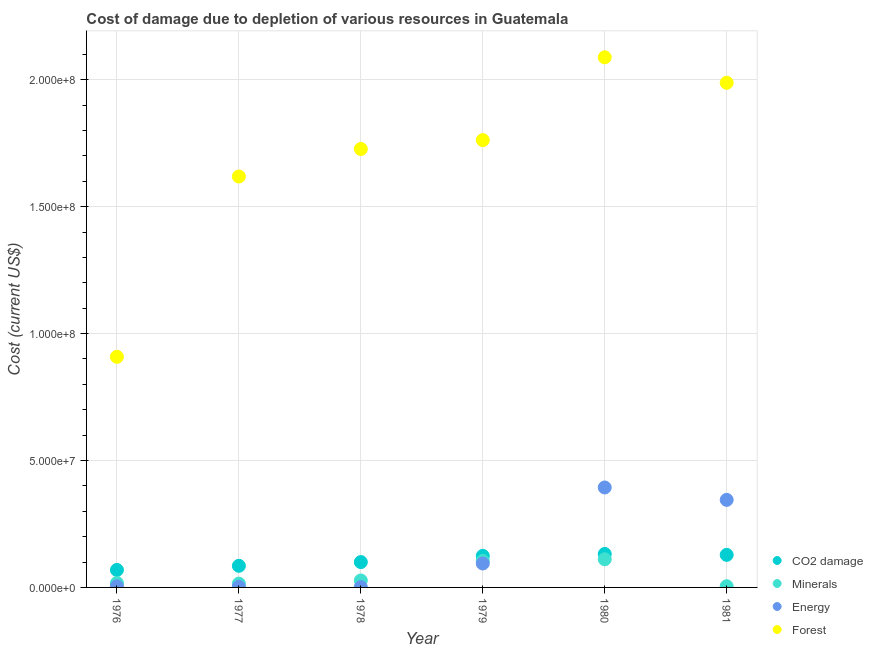Is the number of dotlines equal to the number of legend labels?
Your response must be concise. Yes. What is the cost of damage due to depletion of coal in 1981?
Your answer should be compact. 1.28e+07. Across all years, what is the maximum cost of damage due to depletion of energy?
Your answer should be compact. 3.94e+07. Across all years, what is the minimum cost of damage due to depletion of energy?
Provide a succinct answer. 1.10e+05. In which year was the cost of damage due to depletion of energy maximum?
Offer a terse response. 1980. In which year was the cost of damage due to depletion of coal minimum?
Your response must be concise. 1976. What is the total cost of damage due to depletion of minerals in the graph?
Your response must be concise. 2.80e+07. What is the difference between the cost of damage due to depletion of coal in 1976 and that in 1979?
Your response must be concise. -5.55e+06. What is the difference between the cost of damage due to depletion of minerals in 1981 and the cost of damage due to depletion of forests in 1980?
Give a very brief answer. -2.08e+08. What is the average cost of damage due to depletion of minerals per year?
Keep it short and to the point. 4.67e+06. In the year 1977, what is the difference between the cost of damage due to depletion of minerals and cost of damage due to depletion of coal?
Give a very brief answer. -7.02e+06. What is the ratio of the cost of damage due to depletion of forests in 1980 to that in 1981?
Your answer should be very brief. 1.05. Is the cost of damage due to depletion of forests in 1977 less than that in 1981?
Give a very brief answer. Yes. Is the difference between the cost of damage due to depletion of energy in 1976 and 1977 greater than the difference between the cost of damage due to depletion of forests in 1976 and 1977?
Your answer should be very brief. Yes. What is the difference between the highest and the second highest cost of damage due to depletion of minerals?
Provide a succinct answer. 6.16e+05. What is the difference between the highest and the lowest cost of damage due to depletion of energy?
Make the answer very short. 3.93e+07. Is the sum of the cost of damage due to depletion of coal in 1980 and 1981 greater than the maximum cost of damage due to depletion of energy across all years?
Provide a succinct answer. No. Is it the case that in every year, the sum of the cost of damage due to depletion of forests and cost of damage due to depletion of energy is greater than the sum of cost of damage due to depletion of minerals and cost of damage due to depletion of coal?
Your response must be concise. No. Is it the case that in every year, the sum of the cost of damage due to depletion of coal and cost of damage due to depletion of minerals is greater than the cost of damage due to depletion of energy?
Provide a short and direct response. No. Does the cost of damage due to depletion of forests monotonically increase over the years?
Provide a short and direct response. No. How many years are there in the graph?
Give a very brief answer. 6. What is the difference between two consecutive major ticks on the Y-axis?
Provide a short and direct response. 5.00e+07. Are the values on the major ticks of Y-axis written in scientific E-notation?
Keep it short and to the point. Yes. Does the graph contain any zero values?
Your response must be concise. No. Does the graph contain grids?
Offer a terse response. Yes. Where does the legend appear in the graph?
Provide a short and direct response. Bottom right. How many legend labels are there?
Offer a very short reply. 4. How are the legend labels stacked?
Your response must be concise. Vertical. What is the title of the graph?
Offer a very short reply. Cost of damage due to depletion of various resources in Guatemala . What is the label or title of the Y-axis?
Make the answer very short. Cost (current US$). What is the Cost (current US$) in CO2 damage in 1976?
Keep it short and to the point. 6.88e+06. What is the Cost (current US$) of Minerals in 1976?
Your answer should be compact. 1.73e+06. What is the Cost (current US$) in Energy in 1976?
Your answer should be compact. 4.30e+05. What is the Cost (current US$) in Forest in 1976?
Your answer should be compact. 9.09e+07. What is the Cost (current US$) in CO2 damage in 1977?
Make the answer very short. 8.52e+06. What is the Cost (current US$) in Minerals in 1977?
Offer a very short reply. 1.50e+06. What is the Cost (current US$) in Energy in 1977?
Your response must be concise. 2.50e+05. What is the Cost (current US$) of Forest in 1977?
Make the answer very short. 1.62e+08. What is the Cost (current US$) of CO2 damage in 1978?
Offer a terse response. 9.99e+06. What is the Cost (current US$) in Minerals in 1978?
Give a very brief answer. 2.74e+06. What is the Cost (current US$) in Energy in 1978?
Make the answer very short. 1.10e+05. What is the Cost (current US$) in Forest in 1978?
Offer a very short reply. 1.73e+08. What is the Cost (current US$) of CO2 damage in 1979?
Make the answer very short. 1.24e+07. What is the Cost (current US$) in Minerals in 1979?
Make the answer very short. 1.05e+07. What is the Cost (current US$) of Energy in 1979?
Your answer should be very brief. 9.43e+06. What is the Cost (current US$) in Forest in 1979?
Your response must be concise. 1.76e+08. What is the Cost (current US$) in CO2 damage in 1980?
Your response must be concise. 1.32e+07. What is the Cost (current US$) of Minerals in 1980?
Offer a very short reply. 1.11e+07. What is the Cost (current US$) in Energy in 1980?
Make the answer very short. 3.94e+07. What is the Cost (current US$) of Forest in 1980?
Keep it short and to the point. 2.09e+08. What is the Cost (current US$) in CO2 damage in 1981?
Provide a short and direct response. 1.28e+07. What is the Cost (current US$) of Minerals in 1981?
Offer a terse response. 4.74e+05. What is the Cost (current US$) in Energy in 1981?
Offer a very short reply. 3.45e+07. What is the Cost (current US$) in Forest in 1981?
Offer a very short reply. 1.99e+08. Across all years, what is the maximum Cost (current US$) in CO2 damage?
Your answer should be compact. 1.32e+07. Across all years, what is the maximum Cost (current US$) in Minerals?
Your answer should be very brief. 1.11e+07. Across all years, what is the maximum Cost (current US$) in Energy?
Offer a very short reply. 3.94e+07. Across all years, what is the maximum Cost (current US$) in Forest?
Make the answer very short. 2.09e+08. Across all years, what is the minimum Cost (current US$) of CO2 damage?
Your answer should be very brief. 6.88e+06. Across all years, what is the minimum Cost (current US$) of Minerals?
Give a very brief answer. 4.74e+05. Across all years, what is the minimum Cost (current US$) in Energy?
Keep it short and to the point. 1.10e+05. Across all years, what is the minimum Cost (current US$) in Forest?
Offer a terse response. 9.09e+07. What is the total Cost (current US$) in CO2 damage in the graph?
Ensure brevity in your answer.  6.38e+07. What is the total Cost (current US$) of Minerals in the graph?
Provide a short and direct response. 2.80e+07. What is the total Cost (current US$) in Energy in the graph?
Provide a short and direct response. 8.41e+07. What is the total Cost (current US$) of Forest in the graph?
Your answer should be very brief. 1.01e+09. What is the difference between the Cost (current US$) in CO2 damage in 1976 and that in 1977?
Keep it short and to the point. -1.64e+06. What is the difference between the Cost (current US$) in Minerals in 1976 and that in 1977?
Ensure brevity in your answer.  2.34e+05. What is the difference between the Cost (current US$) of Energy in 1976 and that in 1977?
Offer a very short reply. 1.80e+05. What is the difference between the Cost (current US$) of Forest in 1976 and that in 1977?
Keep it short and to the point. -7.10e+07. What is the difference between the Cost (current US$) in CO2 damage in 1976 and that in 1978?
Keep it short and to the point. -3.10e+06. What is the difference between the Cost (current US$) in Minerals in 1976 and that in 1978?
Provide a succinct answer. -1.01e+06. What is the difference between the Cost (current US$) of Energy in 1976 and that in 1978?
Your answer should be very brief. 3.21e+05. What is the difference between the Cost (current US$) of Forest in 1976 and that in 1978?
Your answer should be compact. -8.19e+07. What is the difference between the Cost (current US$) in CO2 damage in 1976 and that in 1979?
Keep it short and to the point. -5.55e+06. What is the difference between the Cost (current US$) of Minerals in 1976 and that in 1979?
Keep it short and to the point. -8.75e+06. What is the difference between the Cost (current US$) of Energy in 1976 and that in 1979?
Make the answer very short. -9.00e+06. What is the difference between the Cost (current US$) in Forest in 1976 and that in 1979?
Your answer should be very brief. -8.54e+07. What is the difference between the Cost (current US$) of CO2 damage in 1976 and that in 1980?
Offer a very short reply. -6.30e+06. What is the difference between the Cost (current US$) of Minerals in 1976 and that in 1980?
Offer a very short reply. -9.37e+06. What is the difference between the Cost (current US$) in Energy in 1976 and that in 1980?
Provide a short and direct response. -3.89e+07. What is the difference between the Cost (current US$) in Forest in 1976 and that in 1980?
Offer a very short reply. -1.18e+08. What is the difference between the Cost (current US$) in CO2 damage in 1976 and that in 1981?
Give a very brief answer. -5.94e+06. What is the difference between the Cost (current US$) of Minerals in 1976 and that in 1981?
Your answer should be very brief. 1.26e+06. What is the difference between the Cost (current US$) in Energy in 1976 and that in 1981?
Give a very brief answer. -3.41e+07. What is the difference between the Cost (current US$) of Forest in 1976 and that in 1981?
Make the answer very short. -1.08e+08. What is the difference between the Cost (current US$) of CO2 damage in 1977 and that in 1978?
Your answer should be compact. -1.47e+06. What is the difference between the Cost (current US$) of Minerals in 1977 and that in 1978?
Provide a short and direct response. -1.25e+06. What is the difference between the Cost (current US$) of Energy in 1977 and that in 1978?
Offer a very short reply. 1.41e+05. What is the difference between the Cost (current US$) of Forest in 1977 and that in 1978?
Provide a short and direct response. -1.08e+07. What is the difference between the Cost (current US$) of CO2 damage in 1977 and that in 1979?
Give a very brief answer. -3.92e+06. What is the difference between the Cost (current US$) in Minerals in 1977 and that in 1979?
Offer a terse response. -8.98e+06. What is the difference between the Cost (current US$) in Energy in 1977 and that in 1979?
Ensure brevity in your answer.  -9.18e+06. What is the difference between the Cost (current US$) of Forest in 1977 and that in 1979?
Your response must be concise. -1.43e+07. What is the difference between the Cost (current US$) in CO2 damage in 1977 and that in 1980?
Provide a succinct answer. -4.66e+06. What is the difference between the Cost (current US$) in Minerals in 1977 and that in 1980?
Offer a terse response. -9.60e+06. What is the difference between the Cost (current US$) in Energy in 1977 and that in 1980?
Your response must be concise. -3.91e+07. What is the difference between the Cost (current US$) of Forest in 1977 and that in 1980?
Give a very brief answer. -4.70e+07. What is the difference between the Cost (current US$) in CO2 damage in 1977 and that in 1981?
Offer a terse response. -4.31e+06. What is the difference between the Cost (current US$) of Minerals in 1977 and that in 1981?
Keep it short and to the point. 1.02e+06. What is the difference between the Cost (current US$) of Energy in 1977 and that in 1981?
Keep it short and to the point. -3.42e+07. What is the difference between the Cost (current US$) in Forest in 1977 and that in 1981?
Offer a very short reply. -3.69e+07. What is the difference between the Cost (current US$) in CO2 damage in 1978 and that in 1979?
Offer a very short reply. -2.45e+06. What is the difference between the Cost (current US$) of Minerals in 1978 and that in 1979?
Keep it short and to the point. -7.74e+06. What is the difference between the Cost (current US$) in Energy in 1978 and that in 1979?
Offer a terse response. -9.32e+06. What is the difference between the Cost (current US$) in Forest in 1978 and that in 1979?
Keep it short and to the point. -3.50e+06. What is the difference between the Cost (current US$) in CO2 damage in 1978 and that in 1980?
Ensure brevity in your answer.  -3.19e+06. What is the difference between the Cost (current US$) in Minerals in 1978 and that in 1980?
Give a very brief answer. -8.35e+06. What is the difference between the Cost (current US$) in Energy in 1978 and that in 1980?
Your answer should be very brief. -3.93e+07. What is the difference between the Cost (current US$) of Forest in 1978 and that in 1980?
Offer a terse response. -3.61e+07. What is the difference between the Cost (current US$) of CO2 damage in 1978 and that in 1981?
Offer a very short reply. -2.84e+06. What is the difference between the Cost (current US$) of Minerals in 1978 and that in 1981?
Keep it short and to the point. 2.27e+06. What is the difference between the Cost (current US$) in Energy in 1978 and that in 1981?
Your answer should be very brief. -3.44e+07. What is the difference between the Cost (current US$) in Forest in 1978 and that in 1981?
Your answer should be very brief. -2.61e+07. What is the difference between the Cost (current US$) of CO2 damage in 1979 and that in 1980?
Ensure brevity in your answer.  -7.45e+05. What is the difference between the Cost (current US$) of Minerals in 1979 and that in 1980?
Keep it short and to the point. -6.16e+05. What is the difference between the Cost (current US$) in Energy in 1979 and that in 1980?
Your answer should be compact. -2.99e+07. What is the difference between the Cost (current US$) of Forest in 1979 and that in 1980?
Offer a terse response. -3.26e+07. What is the difference between the Cost (current US$) in CO2 damage in 1979 and that in 1981?
Provide a short and direct response. -3.90e+05. What is the difference between the Cost (current US$) in Minerals in 1979 and that in 1981?
Make the answer very short. 1.00e+07. What is the difference between the Cost (current US$) of Energy in 1979 and that in 1981?
Make the answer very short. -2.51e+07. What is the difference between the Cost (current US$) in Forest in 1979 and that in 1981?
Offer a terse response. -2.26e+07. What is the difference between the Cost (current US$) of CO2 damage in 1980 and that in 1981?
Offer a terse response. 3.55e+05. What is the difference between the Cost (current US$) in Minerals in 1980 and that in 1981?
Your answer should be compact. 1.06e+07. What is the difference between the Cost (current US$) in Energy in 1980 and that in 1981?
Keep it short and to the point. 4.89e+06. What is the difference between the Cost (current US$) in Forest in 1980 and that in 1981?
Keep it short and to the point. 1.00e+07. What is the difference between the Cost (current US$) of CO2 damage in 1976 and the Cost (current US$) of Minerals in 1977?
Your answer should be very brief. 5.39e+06. What is the difference between the Cost (current US$) in CO2 damage in 1976 and the Cost (current US$) in Energy in 1977?
Make the answer very short. 6.63e+06. What is the difference between the Cost (current US$) in CO2 damage in 1976 and the Cost (current US$) in Forest in 1977?
Give a very brief answer. -1.55e+08. What is the difference between the Cost (current US$) of Minerals in 1976 and the Cost (current US$) of Energy in 1977?
Make the answer very short. 1.48e+06. What is the difference between the Cost (current US$) of Minerals in 1976 and the Cost (current US$) of Forest in 1977?
Give a very brief answer. -1.60e+08. What is the difference between the Cost (current US$) of Energy in 1976 and the Cost (current US$) of Forest in 1977?
Ensure brevity in your answer.  -1.61e+08. What is the difference between the Cost (current US$) in CO2 damage in 1976 and the Cost (current US$) in Minerals in 1978?
Give a very brief answer. 4.14e+06. What is the difference between the Cost (current US$) in CO2 damage in 1976 and the Cost (current US$) in Energy in 1978?
Provide a succinct answer. 6.77e+06. What is the difference between the Cost (current US$) in CO2 damage in 1976 and the Cost (current US$) in Forest in 1978?
Offer a very short reply. -1.66e+08. What is the difference between the Cost (current US$) of Minerals in 1976 and the Cost (current US$) of Energy in 1978?
Your response must be concise. 1.62e+06. What is the difference between the Cost (current US$) in Minerals in 1976 and the Cost (current US$) in Forest in 1978?
Your answer should be compact. -1.71e+08. What is the difference between the Cost (current US$) of Energy in 1976 and the Cost (current US$) of Forest in 1978?
Keep it short and to the point. -1.72e+08. What is the difference between the Cost (current US$) in CO2 damage in 1976 and the Cost (current US$) in Minerals in 1979?
Make the answer very short. -3.60e+06. What is the difference between the Cost (current US$) of CO2 damage in 1976 and the Cost (current US$) of Energy in 1979?
Your answer should be compact. -2.55e+06. What is the difference between the Cost (current US$) in CO2 damage in 1976 and the Cost (current US$) in Forest in 1979?
Provide a succinct answer. -1.69e+08. What is the difference between the Cost (current US$) of Minerals in 1976 and the Cost (current US$) of Energy in 1979?
Your answer should be very brief. -7.71e+06. What is the difference between the Cost (current US$) in Minerals in 1976 and the Cost (current US$) in Forest in 1979?
Ensure brevity in your answer.  -1.74e+08. What is the difference between the Cost (current US$) in Energy in 1976 and the Cost (current US$) in Forest in 1979?
Offer a terse response. -1.76e+08. What is the difference between the Cost (current US$) in CO2 damage in 1976 and the Cost (current US$) in Minerals in 1980?
Give a very brief answer. -4.21e+06. What is the difference between the Cost (current US$) of CO2 damage in 1976 and the Cost (current US$) of Energy in 1980?
Your answer should be very brief. -3.25e+07. What is the difference between the Cost (current US$) in CO2 damage in 1976 and the Cost (current US$) in Forest in 1980?
Keep it short and to the point. -2.02e+08. What is the difference between the Cost (current US$) in Minerals in 1976 and the Cost (current US$) in Energy in 1980?
Give a very brief answer. -3.77e+07. What is the difference between the Cost (current US$) of Minerals in 1976 and the Cost (current US$) of Forest in 1980?
Make the answer very short. -2.07e+08. What is the difference between the Cost (current US$) in Energy in 1976 and the Cost (current US$) in Forest in 1980?
Your answer should be compact. -2.08e+08. What is the difference between the Cost (current US$) of CO2 damage in 1976 and the Cost (current US$) of Minerals in 1981?
Make the answer very short. 6.41e+06. What is the difference between the Cost (current US$) in CO2 damage in 1976 and the Cost (current US$) in Energy in 1981?
Offer a very short reply. -2.76e+07. What is the difference between the Cost (current US$) of CO2 damage in 1976 and the Cost (current US$) of Forest in 1981?
Your answer should be compact. -1.92e+08. What is the difference between the Cost (current US$) of Minerals in 1976 and the Cost (current US$) of Energy in 1981?
Provide a short and direct response. -3.28e+07. What is the difference between the Cost (current US$) of Minerals in 1976 and the Cost (current US$) of Forest in 1981?
Give a very brief answer. -1.97e+08. What is the difference between the Cost (current US$) in Energy in 1976 and the Cost (current US$) in Forest in 1981?
Give a very brief answer. -1.98e+08. What is the difference between the Cost (current US$) of CO2 damage in 1977 and the Cost (current US$) of Minerals in 1978?
Make the answer very short. 5.78e+06. What is the difference between the Cost (current US$) of CO2 damage in 1977 and the Cost (current US$) of Energy in 1978?
Your response must be concise. 8.41e+06. What is the difference between the Cost (current US$) in CO2 damage in 1977 and the Cost (current US$) in Forest in 1978?
Offer a terse response. -1.64e+08. What is the difference between the Cost (current US$) in Minerals in 1977 and the Cost (current US$) in Energy in 1978?
Provide a short and direct response. 1.39e+06. What is the difference between the Cost (current US$) in Minerals in 1977 and the Cost (current US$) in Forest in 1978?
Your response must be concise. -1.71e+08. What is the difference between the Cost (current US$) of Energy in 1977 and the Cost (current US$) of Forest in 1978?
Provide a short and direct response. -1.72e+08. What is the difference between the Cost (current US$) of CO2 damage in 1977 and the Cost (current US$) of Minerals in 1979?
Make the answer very short. -1.96e+06. What is the difference between the Cost (current US$) of CO2 damage in 1977 and the Cost (current US$) of Energy in 1979?
Make the answer very short. -9.16e+05. What is the difference between the Cost (current US$) of CO2 damage in 1977 and the Cost (current US$) of Forest in 1979?
Keep it short and to the point. -1.68e+08. What is the difference between the Cost (current US$) in Minerals in 1977 and the Cost (current US$) in Energy in 1979?
Your response must be concise. -7.94e+06. What is the difference between the Cost (current US$) in Minerals in 1977 and the Cost (current US$) in Forest in 1979?
Offer a terse response. -1.75e+08. What is the difference between the Cost (current US$) in Energy in 1977 and the Cost (current US$) in Forest in 1979?
Your response must be concise. -1.76e+08. What is the difference between the Cost (current US$) in CO2 damage in 1977 and the Cost (current US$) in Minerals in 1980?
Make the answer very short. -2.58e+06. What is the difference between the Cost (current US$) in CO2 damage in 1977 and the Cost (current US$) in Energy in 1980?
Provide a short and direct response. -3.09e+07. What is the difference between the Cost (current US$) of CO2 damage in 1977 and the Cost (current US$) of Forest in 1980?
Provide a short and direct response. -2.00e+08. What is the difference between the Cost (current US$) of Minerals in 1977 and the Cost (current US$) of Energy in 1980?
Offer a very short reply. -3.79e+07. What is the difference between the Cost (current US$) in Minerals in 1977 and the Cost (current US$) in Forest in 1980?
Provide a short and direct response. -2.07e+08. What is the difference between the Cost (current US$) of Energy in 1977 and the Cost (current US$) of Forest in 1980?
Provide a succinct answer. -2.09e+08. What is the difference between the Cost (current US$) in CO2 damage in 1977 and the Cost (current US$) in Minerals in 1981?
Your answer should be compact. 8.05e+06. What is the difference between the Cost (current US$) of CO2 damage in 1977 and the Cost (current US$) of Energy in 1981?
Provide a short and direct response. -2.60e+07. What is the difference between the Cost (current US$) of CO2 damage in 1977 and the Cost (current US$) of Forest in 1981?
Ensure brevity in your answer.  -1.90e+08. What is the difference between the Cost (current US$) of Minerals in 1977 and the Cost (current US$) of Energy in 1981?
Give a very brief answer. -3.30e+07. What is the difference between the Cost (current US$) in Minerals in 1977 and the Cost (current US$) in Forest in 1981?
Your answer should be very brief. -1.97e+08. What is the difference between the Cost (current US$) of Energy in 1977 and the Cost (current US$) of Forest in 1981?
Offer a very short reply. -1.99e+08. What is the difference between the Cost (current US$) in CO2 damage in 1978 and the Cost (current US$) in Minerals in 1979?
Offer a terse response. -4.92e+05. What is the difference between the Cost (current US$) of CO2 damage in 1978 and the Cost (current US$) of Energy in 1979?
Your answer should be very brief. 5.52e+05. What is the difference between the Cost (current US$) of CO2 damage in 1978 and the Cost (current US$) of Forest in 1979?
Offer a very short reply. -1.66e+08. What is the difference between the Cost (current US$) in Minerals in 1978 and the Cost (current US$) in Energy in 1979?
Ensure brevity in your answer.  -6.69e+06. What is the difference between the Cost (current US$) of Minerals in 1978 and the Cost (current US$) of Forest in 1979?
Ensure brevity in your answer.  -1.73e+08. What is the difference between the Cost (current US$) in Energy in 1978 and the Cost (current US$) in Forest in 1979?
Your answer should be compact. -1.76e+08. What is the difference between the Cost (current US$) in CO2 damage in 1978 and the Cost (current US$) in Minerals in 1980?
Provide a succinct answer. -1.11e+06. What is the difference between the Cost (current US$) of CO2 damage in 1978 and the Cost (current US$) of Energy in 1980?
Ensure brevity in your answer.  -2.94e+07. What is the difference between the Cost (current US$) in CO2 damage in 1978 and the Cost (current US$) in Forest in 1980?
Your response must be concise. -1.99e+08. What is the difference between the Cost (current US$) in Minerals in 1978 and the Cost (current US$) in Energy in 1980?
Keep it short and to the point. -3.66e+07. What is the difference between the Cost (current US$) of Minerals in 1978 and the Cost (current US$) of Forest in 1980?
Ensure brevity in your answer.  -2.06e+08. What is the difference between the Cost (current US$) in Energy in 1978 and the Cost (current US$) in Forest in 1980?
Keep it short and to the point. -2.09e+08. What is the difference between the Cost (current US$) of CO2 damage in 1978 and the Cost (current US$) of Minerals in 1981?
Give a very brief answer. 9.51e+06. What is the difference between the Cost (current US$) of CO2 damage in 1978 and the Cost (current US$) of Energy in 1981?
Make the answer very short. -2.45e+07. What is the difference between the Cost (current US$) in CO2 damage in 1978 and the Cost (current US$) in Forest in 1981?
Your response must be concise. -1.89e+08. What is the difference between the Cost (current US$) of Minerals in 1978 and the Cost (current US$) of Energy in 1981?
Your response must be concise. -3.18e+07. What is the difference between the Cost (current US$) of Minerals in 1978 and the Cost (current US$) of Forest in 1981?
Give a very brief answer. -1.96e+08. What is the difference between the Cost (current US$) of Energy in 1978 and the Cost (current US$) of Forest in 1981?
Your answer should be very brief. -1.99e+08. What is the difference between the Cost (current US$) in CO2 damage in 1979 and the Cost (current US$) in Minerals in 1980?
Keep it short and to the point. 1.34e+06. What is the difference between the Cost (current US$) of CO2 damage in 1979 and the Cost (current US$) of Energy in 1980?
Keep it short and to the point. -2.69e+07. What is the difference between the Cost (current US$) in CO2 damage in 1979 and the Cost (current US$) in Forest in 1980?
Make the answer very short. -1.96e+08. What is the difference between the Cost (current US$) of Minerals in 1979 and the Cost (current US$) of Energy in 1980?
Make the answer very short. -2.89e+07. What is the difference between the Cost (current US$) of Minerals in 1979 and the Cost (current US$) of Forest in 1980?
Keep it short and to the point. -1.98e+08. What is the difference between the Cost (current US$) of Energy in 1979 and the Cost (current US$) of Forest in 1980?
Your response must be concise. -1.99e+08. What is the difference between the Cost (current US$) of CO2 damage in 1979 and the Cost (current US$) of Minerals in 1981?
Provide a short and direct response. 1.20e+07. What is the difference between the Cost (current US$) in CO2 damage in 1979 and the Cost (current US$) in Energy in 1981?
Your answer should be very brief. -2.21e+07. What is the difference between the Cost (current US$) of CO2 damage in 1979 and the Cost (current US$) of Forest in 1981?
Your answer should be compact. -1.86e+08. What is the difference between the Cost (current US$) in Minerals in 1979 and the Cost (current US$) in Energy in 1981?
Make the answer very short. -2.40e+07. What is the difference between the Cost (current US$) of Minerals in 1979 and the Cost (current US$) of Forest in 1981?
Your answer should be very brief. -1.88e+08. What is the difference between the Cost (current US$) in Energy in 1979 and the Cost (current US$) in Forest in 1981?
Offer a terse response. -1.89e+08. What is the difference between the Cost (current US$) of CO2 damage in 1980 and the Cost (current US$) of Minerals in 1981?
Give a very brief answer. 1.27e+07. What is the difference between the Cost (current US$) of CO2 damage in 1980 and the Cost (current US$) of Energy in 1981?
Your answer should be very brief. -2.13e+07. What is the difference between the Cost (current US$) of CO2 damage in 1980 and the Cost (current US$) of Forest in 1981?
Ensure brevity in your answer.  -1.86e+08. What is the difference between the Cost (current US$) in Minerals in 1980 and the Cost (current US$) in Energy in 1981?
Provide a short and direct response. -2.34e+07. What is the difference between the Cost (current US$) in Minerals in 1980 and the Cost (current US$) in Forest in 1981?
Make the answer very short. -1.88e+08. What is the difference between the Cost (current US$) in Energy in 1980 and the Cost (current US$) in Forest in 1981?
Give a very brief answer. -1.59e+08. What is the average Cost (current US$) in CO2 damage per year?
Offer a terse response. 1.06e+07. What is the average Cost (current US$) in Minerals per year?
Provide a succinct answer. 4.67e+06. What is the average Cost (current US$) of Energy per year?
Provide a short and direct response. 1.40e+07. What is the average Cost (current US$) of Forest per year?
Keep it short and to the point. 1.68e+08. In the year 1976, what is the difference between the Cost (current US$) of CO2 damage and Cost (current US$) of Minerals?
Give a very brief answer. 5.15e+06. In the year 1976, what is the difference between the Cost (current US$) in CO2 damage and Cost (current US$) in Energy?
Provide a succinct answer. 6.45e+06. In the year 1976, what is the difference between the Cost (current US$) of CO2 damage and Cost (current US$) of Forest?
Provide a short and direct response. -8.40e+07. In the year 1976, what is the difference between the Cost (current US$) of Minerals and Cost (current US$) of Energy?
Your answer should be very brief. 1.30e+06. In the year 1976, what is the difference between the Cost (current US$) of Minerals and Cost (current US$) of Forest?
Offer a very short reply. -8.91e+07. In the year 1976, what is the difference between the Cost (current US$) of Energy and Cost (current US$) of Forest?
Your answer should be very brief. -9.04e+07. In the year 1977, what is the difference between the Cost (current US$) of CO2 damage and Cost (current US$) of Minerals?
Offer a very short reply. 7.02e+06. In the year 1977, what is the difference between the Cost (current US$) in CO2 damage and Cost (current US$) in Energy?
Make the answer very short. 8.27e+06. In the year 1977, what is the difference between the Cost (current US$) in CO2 damage and Cost (current US$) in Forest?
Give a very brief answer. -1.53e+08. In the year 1977, what is the difference between the Cost (current US$) of Minerals and Cost (current US$) of Energy?
Provide a short and direct response. 1.24e+06. In the year 1977, what is the difference between the Cost (current US$) in Minerals and Cost (current US$) in Forest?
Keep it short and to the point. -1.60e+08. In the year 1977, what is the difference between the Cost (current US$) of Energy and Cost (current US$) of Forest?
Offer a very short reply. -1.62e+08. In the year 1978, what is the difference between the Cost (current US$) of CO2 damage and Cost (current US$) of Minerals?
Give a very brief answer. 7.25e+06. In the year 1978, what is the difference between the Cost (current US$) of CO2 damage and Cost (current US$) of Energy?
Your answer should be compact. 9.88e+06. In the year 1978, what is the difference between the Cost (current US$) of CO2 damage and Cost (current US$) of Forest?
Offer a terse response. -1.63e+08. In the year 1978, what is the difference between the Cost (current US$) of Minerals and Cost (current US$) of Energy?
Provide a succinct answer. 2.63e+06. In the year 1978, what is the difference between the Cost (current US$) in Minerals and Cost (current US$) in Forest?
Ensure brevity in your answer.  -1.70e+08. In the year 1978, what is the difference between the Cost (current US$) of Energy and Cost (current US$) of Forest?
Provide a succinct answer. -1.73e+08. In the year 1979, what is the difference between the Cost (current US$) of CO2 damage and Cost (current US$) of Minerals?
Ensure brevity in your answer.  1.96e+06. In the year 1979, what is the difference between the Cost (current US$) of CO2 damage and Cost (current US$) of Energy?
Provide a short and direct response. 3.00e+06. In the year 1979, what is the difference between the Cost (current US$) in CO2 damage and Cost (current US$) in Forest?
Your response must be concise. -1.64e+08. In the year 1979, what is the difference between the Cost (current US$) in Minerals and Cost (current US$) in Energy?
Your answer should be compact. 1.04e+06. In the year 1979, what is the difference between the Cost (current US$) of Minerals and Cost (current US$) of Forest?
Ensure brevity in your answer.  -1.66e+08. In the year 1979, what is the difference between the Cost (current US$) of Energy and Cost (current US$) of Forest?
Your answer should be compact. -1.67e+08. In the year 1980, what is the difference between the Cost (current US$) of CO2 damage and Cost (current US$) of Minerals?
Offer a very short reply. 2.08e+06. In the year 1980, what is the difference between the Cost (current US$) of CO2 damage and Cost (current US$) of Energy?
Make the answer very short. -2.62e+07. In the year 1980, what is the difference between the Cost (current US$) of CO2 damage and Cost (current US$) of Forest?
Offer a terse response. -1.96e+08. In the year 1980, what is the difference between the Cost (current US$) of Minerals and Cost (current US$) of Energy?
Provide a short and direct response. -2.83e+07. In the year 1980, what is the difference between the Cost (current US$) of Minerals and Cost (current US$) of Forest?
Ensure brevity in your answer.  -1.98e+08. In the year 1980, what is the difference between the Cost (current US$) in Energy and Cost (current US$) in Forest?
Keep it short and to the point. -1.69e+08. In the year 1981, what is the difference between the Cost (current US$) of CO2 damage and Cost (current US$) of Minerals?
Provide a short and direct response. 1.24e+07. In the year 1981, what is the difference between the Cost (current US$) of CO2 damage and Cost (current US$) of Energy?
Make the answer very short. -2.17e+07. In the year 1981, what is the difference between the Cost (current US$) in CO2 damage and Cost (current US$) in Forest?
Keep it short and to the point. -1.86e+08. In the year 1981, what is the difference between the Cost (current US$) in Minerals and Cost (current US$) in Energy?
Provide a succinct answer. -3.40e+07. In the year 1981, what is the difference between the Cost (current US$) of Minerals and Cost (current US$) of Forest?
Your response must be concise. -1.98e+08. In the year 1981, what is the difference between the Cost (current US$) of Energy and Cost (current US$) of Forest?
Give a very brief answer. -1.64e+08. What is the ratio of the Cost (current US$) in CO2 damage in 1976 to that in 1977?
Keep it short and to the point. 0.81. What is the ratio of the Cost (current US$) in Minerals in 1976 to that in 1977?
Offer a terse response. 1.16. What is the ratio of the Cost (current US$) in Energy in 1976 to that in 1977?
Offer a very short reply. 1.72. What is the ratio of the Cost (current US$) in Forest in 1976 to that in 1977?
Provide a short and direct response. 0.56. What is the ratio of the Cost (current US$) of CO2 damage in 1976 to that in 1978?
Keep it short and to the point. 0.69. What is the ratio of the Cost (current US$) of Minerals in 1976 to that in 1978?
Provide a short and direct response. 0.63. What is the ratio of the Cost (current US$) of Energy in 1976 to that in 1978?
Make the answer very short. 3.92. What is the ratio of the Cost (current US$) of Forest in 1976 to that in 1978?
Your answer should be very brief. 0.53. What is the ratio of the Cost (current US$) in CO2 damage in 1976 to that in 1979?
Provide a succinct answer. 0.55. What is the ratio of the Cost (current US$) of Minerals in 1976 to that in 1979?
Offer a very short reply. 0.17. What is the ratio of the Cost (current US$) in Energy in 1976 to that in 1979?
Make the answer very short. 0.05. What is the ratio of the Cost (current US$) of Forest in 1976 to that in 1979?
Ensure brevity in your answer.  0.52. What is the ratio of the Cost (current US$) of CO2 damage in 1976 to that in 1980?
Provide a short and direct response. 0.52. What is the ratio of the Cost (current US$) in Minerals in 1976 to that in 1980?
Keep it short and to the point. 0.16. What is the ratio of the Cost (current US$) of Energy in 1976 to that in 1980?
Your answer should be very brief. 0.01. What is the ratio of the Cost (current US$) of Forest in 1976 to that in 1980?
Offer a terse response. 0.43. What is the ratio of the Cost (current US$) in CO2 damage in 1976 to that in 1981?
Your answer should be very brief. 0.54. What is the ratio of the Cost (current US$) in Minerals in 1976 to that in 1981?
Provide a succinct answer. 3.65. What is the ratio of the Cost (current US$) in Energy in 1976 to that in 1981?
Ensure brevity in your answer.  0.01. What is the ratio of the Cost (current US$) in Forest in 1976 to that in 1981?
Your answer should be compact. 0.46. What is the ratio of the Cost (current US$) of CO2 damage in 1977 to that in 1978?
Offer a terse response. 0.85. What is the ratio of the Cost (current US$) of Minerals in 1977 to that in 1978?
Offer a terse response. 0.55. What is the ratio of the Cost (current US$) in Energy in 1977 to that in 1978?
Your answer should be compact. 2.28. What is the ratio of the Cost (current US$) of Forest in 1977 to that in 1978?
Provide a succinct answer. 0.94. What is the ratio of the Cost (current US$) of CO2 damage in 1977 to that in 1979?
Your response must be concise. 0.69. What is the ratio of the Cost (current US$) in Minerals in 1977 to that in 1979?
Provide a short and direct response. 0.14. What is the ratio of the Cost (current US$) in Energy in 1977 to that in 1979?
Give a very brief answer. 0.03. What is the ratio of the Cost (current US$) of Forest in 1977 to that in 1979?
Give a very brief answer. 0.92. What is the ratio of the Cost (current US$) in CO2 damage in 1977 to that in 1980?
Provide a succinct answer. 0.65. What is the ratio of the Cost (current US$) of Minerals in 1977 to that in 1980?
Offer a terse response. 0.13. What is the ratio of the Cost (current US$) of Energy in 1977 to that in 1980?
Give a very brief answer. 0.01. What is the ratio of the Cost (current US$) in Forest in 1977 to that in 1980?
Offer a very short reply. 0.78. What is the ratio of the Cost (current US$) in CO2 damage in 1977 to that in 1981?
Give a very brief answer. 0.66. What is the ratio of the Cost (current US$) in Minerals in 1977 to that in 1981?
Make the answer very short. 3.16. What is the ratio of the Cost (current US$) of Energy in 1977 to that in 1981?
Your response must be concise. 0.01. What is the ratio of the Cost (current US$) of Forest in 1977 to that in 1981?
Make the answer very short. 0.81. What is the ratio of the Cost (current US$) in CO2 damage in 1978 to that in 1979?
Provide a short and direct response. 0.8. What is the ratio of the Cost (current US$) of Minerals in 1978 to that in 1979?
Offer a very short reply. 0.26. What is the ratio of the Cost (current US$) of Energy in 1978 to that in 1979?
Offer a very short reply. 0.01. What is the ratio of the Cost (current US$) in Forest in 1978 to that in 1979?
Provide a short and direct response. 0.98. What is the ratio of the Cost (current US$) of CO2 damage in 1978 to that in 1980?
Give a very brief answer. 0.76. What is the ratio of the Cost (current US$) of Minerals in 1978 to that in 1980?
Offer a terse response. 0.25. What is the ratio of the Cost (current US$) in Energy in 1978 to that in 1980?
Keep it short and to the point. 0. What is the ratio of the Cost (current US$) of Forest in 1978 to that in 1980?
Offer a terse response. 0.83. What is the ratio of the Cost (current US$) in CO2 damage in 1978 to that in 1981?
Give a very brief answer. 0.78. What is the ratio of the Cost (current US$) in Minerals in 1978 to that in 1981?
Give a very brief answer. 5.79. What is the ratio of the Cost (current US$) of Energy in 1978 to that in 1981?
Give a very brief answer. 0. What is the ratio of the Cost (current US$) in Forest in 1978 to that in 1981?
Your response must be concise. 0.87. What is the ratio of the Cost (current US$) of CO2 damage in 1979 to that in 1980?
Make the answer very short. 0.94. What is the ratio of the Cost (current US$) in Minerals in 1979 to that in 1980?
Make the answer very short. 0.94. What is the ratio of the Cost (current US$) in Energy in 1979 to that in 1980?
Offer a terse response. 0.24. What is the ratio of the Cost (current US$) of Forest in 1979 to that in 1980?
Provide a short and direct response. 0.84. What is the ratio of the Cost (current US$) of CO2 damage in 1979 to that in 1981?
Provide a succinct answer. 0.97. What is the ratio of the Cost (current US$) in Minerals in 1979 to that in 1981?
Keep it short and to the point. 22.12. What is the ratio of the Cost (current US$) of Energy in 1979 to that in 1981?
Your answer should be very brief. 0.27. What is the ratio of the Cost (current US$) of Forest in 1979 to that in 1981?
Your response must be concise. 0.89. What is the ratio of the Cost (current US$) of CO2 damage in 1980 to that in 1981?
Provide a short and direct response. 1.03. What is the ratio of the Cost (current US$) of Minerals in 1980 to that in 1981?
Offer a very short reply. 23.42. What is the ratio of the Cost (current US$) in Energy in 1980 to that in 1981?
Provide a succinct answer. 1.14. What is the ratio of the Cost (current US$) in Forest in 1980 to that in 1981?
Provide a succinct answer. 1.05. What is the difference between the highest and the second highest Cost (current US$) of CO2 damage?
Give a very brief answer. 3.55e+05. What is the difference between the highest and the second highest Cost (current US$) in Minerals?
Provide a succinct answer. 6.16e+05. What is the difference between the highest and the second highest Cost (current US$) in Energy?
Offer a terse response. 4.89e+06. What is the difference between the highest and the second highest Cost (current US$) of Forest?
Your response must be concise. 1.00e+07. What is the difference between the highest and the lowest Cost (current US$) of CO2 damage?
Give a very brief answer. 6.30e+06. What is the difference between the highest and the lowest Cost (current US$) of Minerals?
Keep it short and to the point. 1.06e+07. What is the difference between the highest and the lowest Cost (current US$) in Energy?
Your answer should be very brief. 3.93e+07. What is the difference between the highest and the lowest Cost (current US$) in Forest?
Offer a terse response. 1.18e+08. 